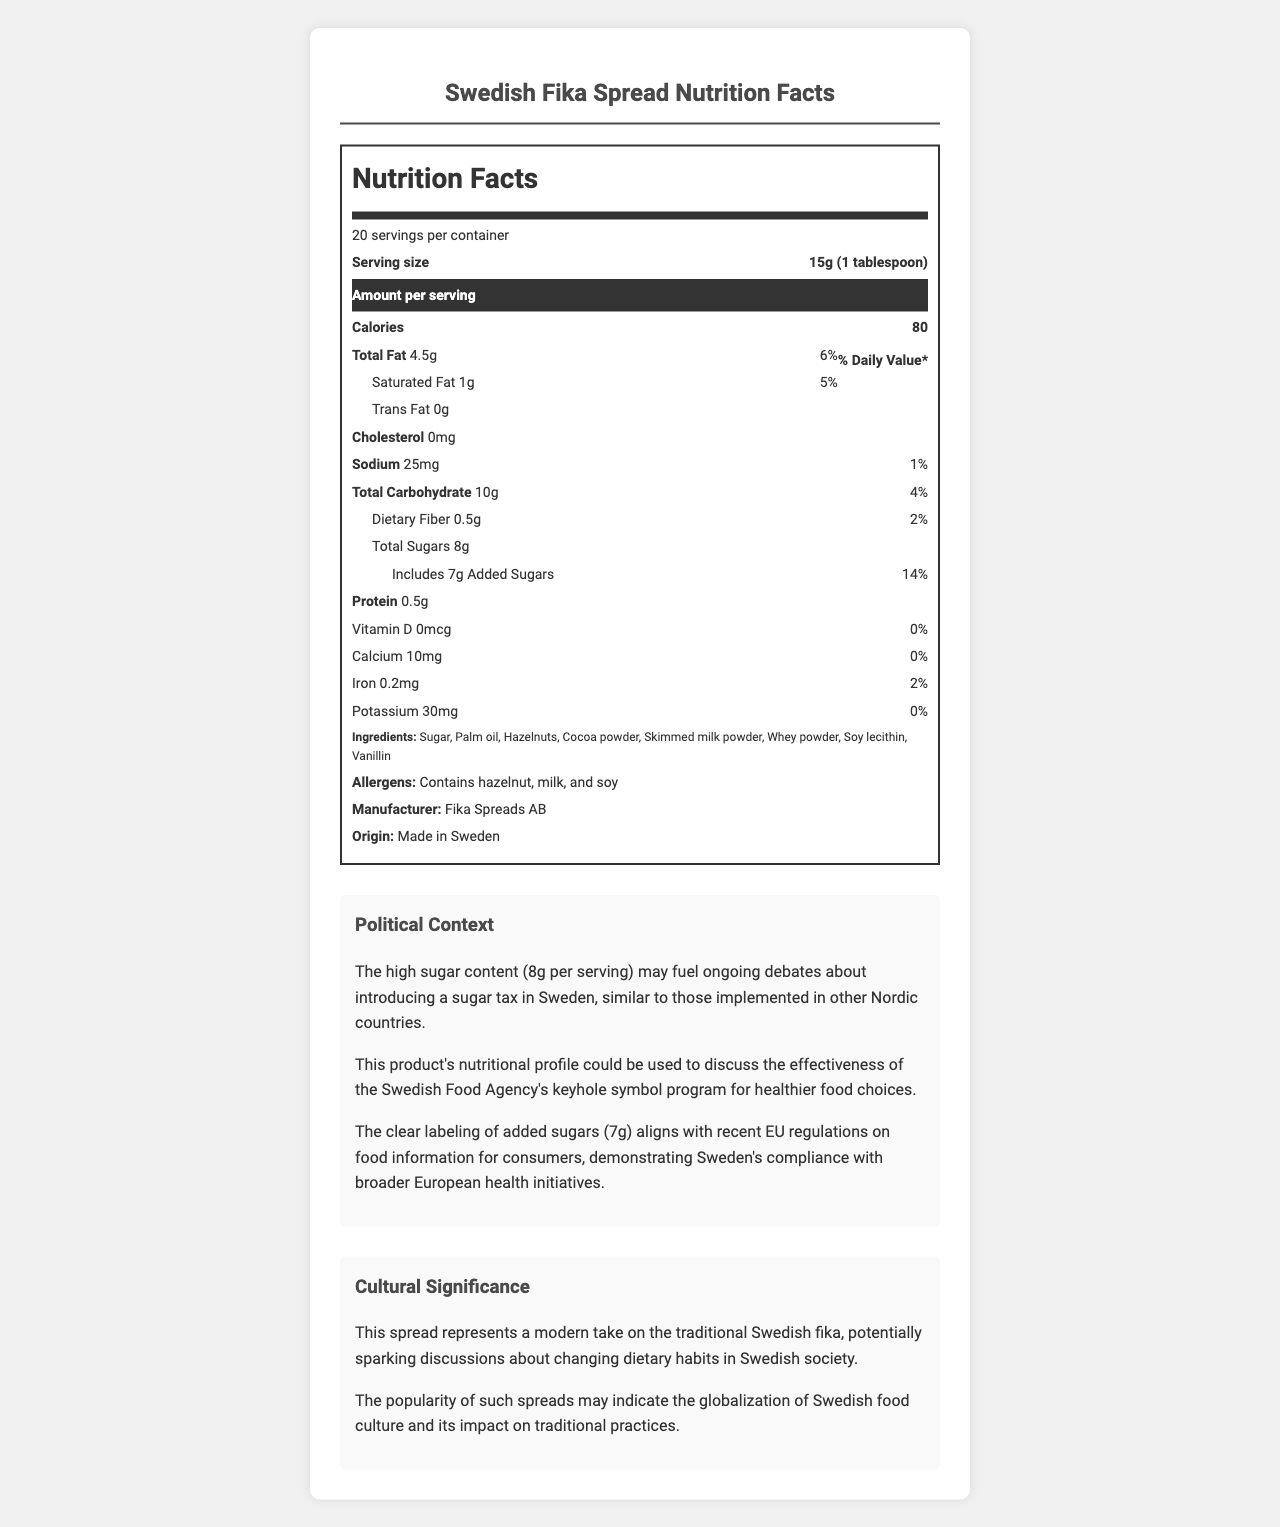who is the manufacturer of the Swedish Fika Spread? The document lists "Manufacturer: Fika Spreads AB".
Answer: Fika Spreads AB how many calories are in one serving of the Swedish Fika Spread? The document states "Calories 80" under the serving size section.
Answer: 80 calories how much added sugar is in one serving of the Swedish Fika Spread? The document lists "Includes 7g Added Sugars" in the nutritional facts section.
Answer: 7g what is the daily value percentage of added sugars in one serving? The document indicates "Includes 7g Added Sugars 14%" under the sugar content.
Answer: 14% how many grams of total sugars are there per serving? The document specifies "Total Sugars 8g" in the nutritional facts section.
Answer: 8g Is there any trans fat in the Swedish Fika Spread? The document clearly states "Trans Fat 0g".
Answer: No how much dietary fiber does one serving of the spread contain? The document mentions "Dietary Fiber 0.5g" in the nutritional facts.
Answer: 0.5g What is the serving size for the Swedish Fika Spread? A. 10g B. 15g C. 20g D. 25g The document states "Serving size: 15g (1 tablespoon)".
Answer: B What is the daily value percentage for total fat in one serving? A. 2% B. 4% C. 6% D. 8% The document lists "Total Fat 4.5g 6%".
Answer: C Which of the following allergens are present in the Swedish Fika Spread? A. Almond B. Milk C. Wheat D. Shellfish The document states "Contains hazelnut, milk, and soy".
Answer: B Is the Swedish Fika Spread made in Sweden? The document specifies "Origin: Made in Sweden".
Answer: Yes Summarize the main idea of the Swedish Fika Spread Nutrition Facts Label. The document is an in-depth nutritional label for the "Swedish Fika Spread," including serving size, nutritional values (fats, sugars, etc.), ingredients, and allergen information. It discusses the socio-political implications of its sugar content, such as potential sugar tax debates and public health initiatives, along with its cultural significance in Swedish fika tradition.
Answer: The Swedish Fika Spread Nutrition Facts Label outlines serving sizes, calorie content, and nutritional breakdown per serving, indicating high sugar content. It includes information on allergens, manufacturer, and origin. The label also discusses the political context surrounding sugar content and public health initiatives, and the cultural significance of fika in Sweden. What is the exact amount of iron in one serving in micrograms? The document lists iron content in milligrams (0.2mg), but does not convert this to micrograms.
Answer: Cannot be determined 